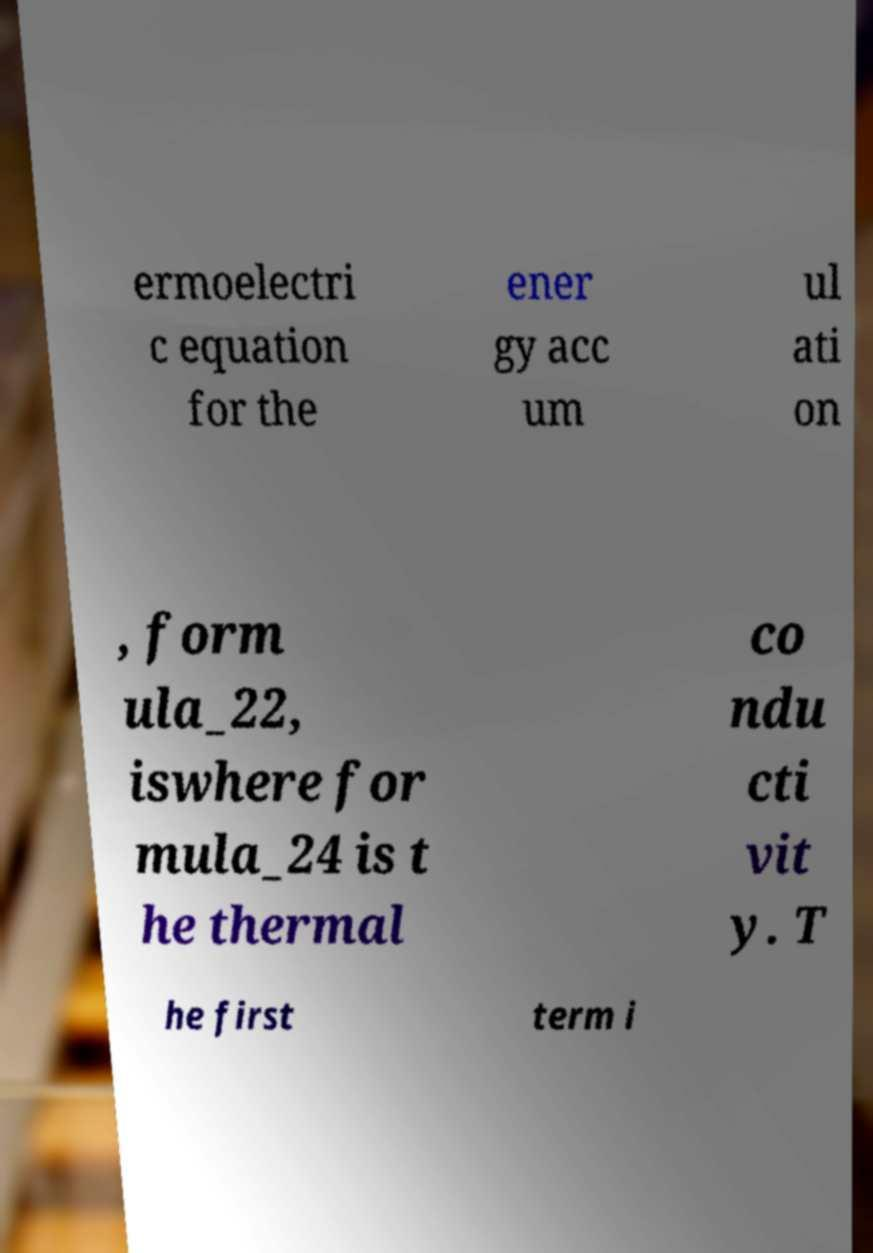What messages or text are displayed in this image? I need them in a readable, typed format. ermoelectri c equation for the ener gy acc um ul ati on , form ula_22, iswhere for mula_24 is t he thermal co ndu cti vit y. T he first term i 